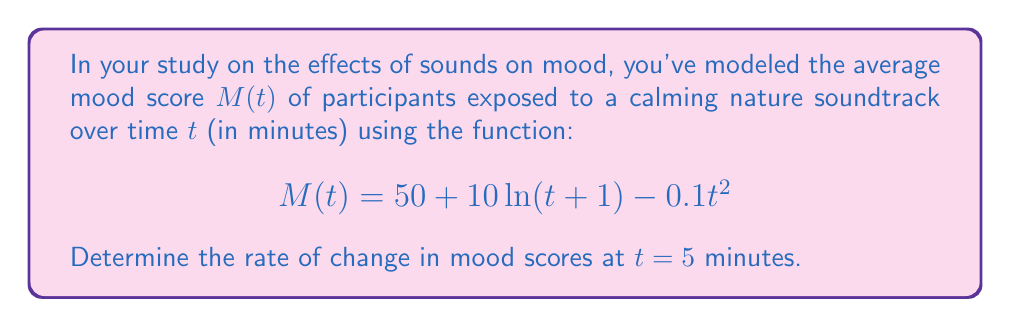Can you answer this question? To find the rate of change in mood scores at a specific time, we need to calculate the derivative of the mood function $M(t)$ and then evaluate it at the given time.

Step 1: Calculate the derivative of $M(t)$
$$M(t) = 50 + 10\ln(t+1) - 0.1t^2$$

Using the rules of differentiation:
- The derivative of a constant (50) is 0
- The derivative of $10\ln(t+1)$ is $\frac{10}{t+1}$
- The derivative of $-0.1t^2$ is $-0.2t$

Therefore, the derivative $M'(t)$ is:

$$M'(t) = \frac{10}{t+1} - 0.2t$$

Step 2: Evaluate $M'(t)$ at $t = 5$
$$M'(5) = \frac{10}{5+1} - 0.2(5)$$
$$M'(5) = \frac{10}{6} - 1$$
$$M'(5) = \frac{5}{3} - 1$$
$$M'(5) = \frac{5}{3} - \frac{3}{3} = \frac{2}{3}$$

The rate of change at $t = 5$ minutes is $\frac{2}{3}$ points per minute.
Answer: $\frac{2}{3}$ points/minute 